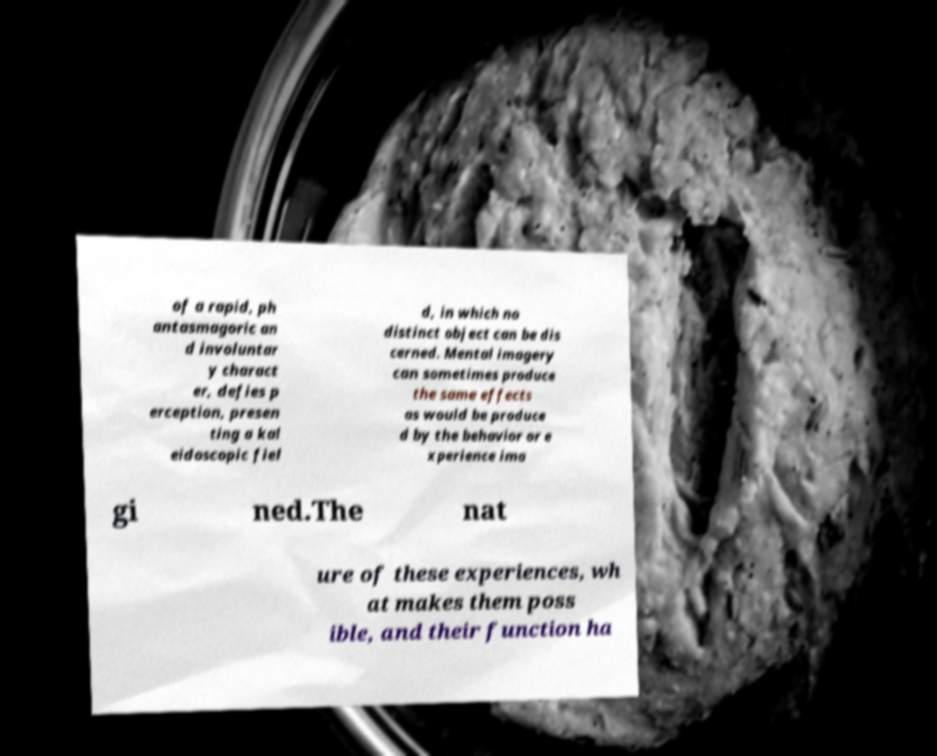Please read and relay the text visible in this image. What does it say? of a rapid, ph antasmagoric an d involuntar y charact er, defies p erception, presen ting a kal eidoscopic fiel d, in which no distinct object can be dis cerned. Mental imagery can sometimes produce the same effects as would be produce d by the behavior or e xperience ima gi ned.The nat ure of these experiences, wh at makes them poss ible, and their function ha 